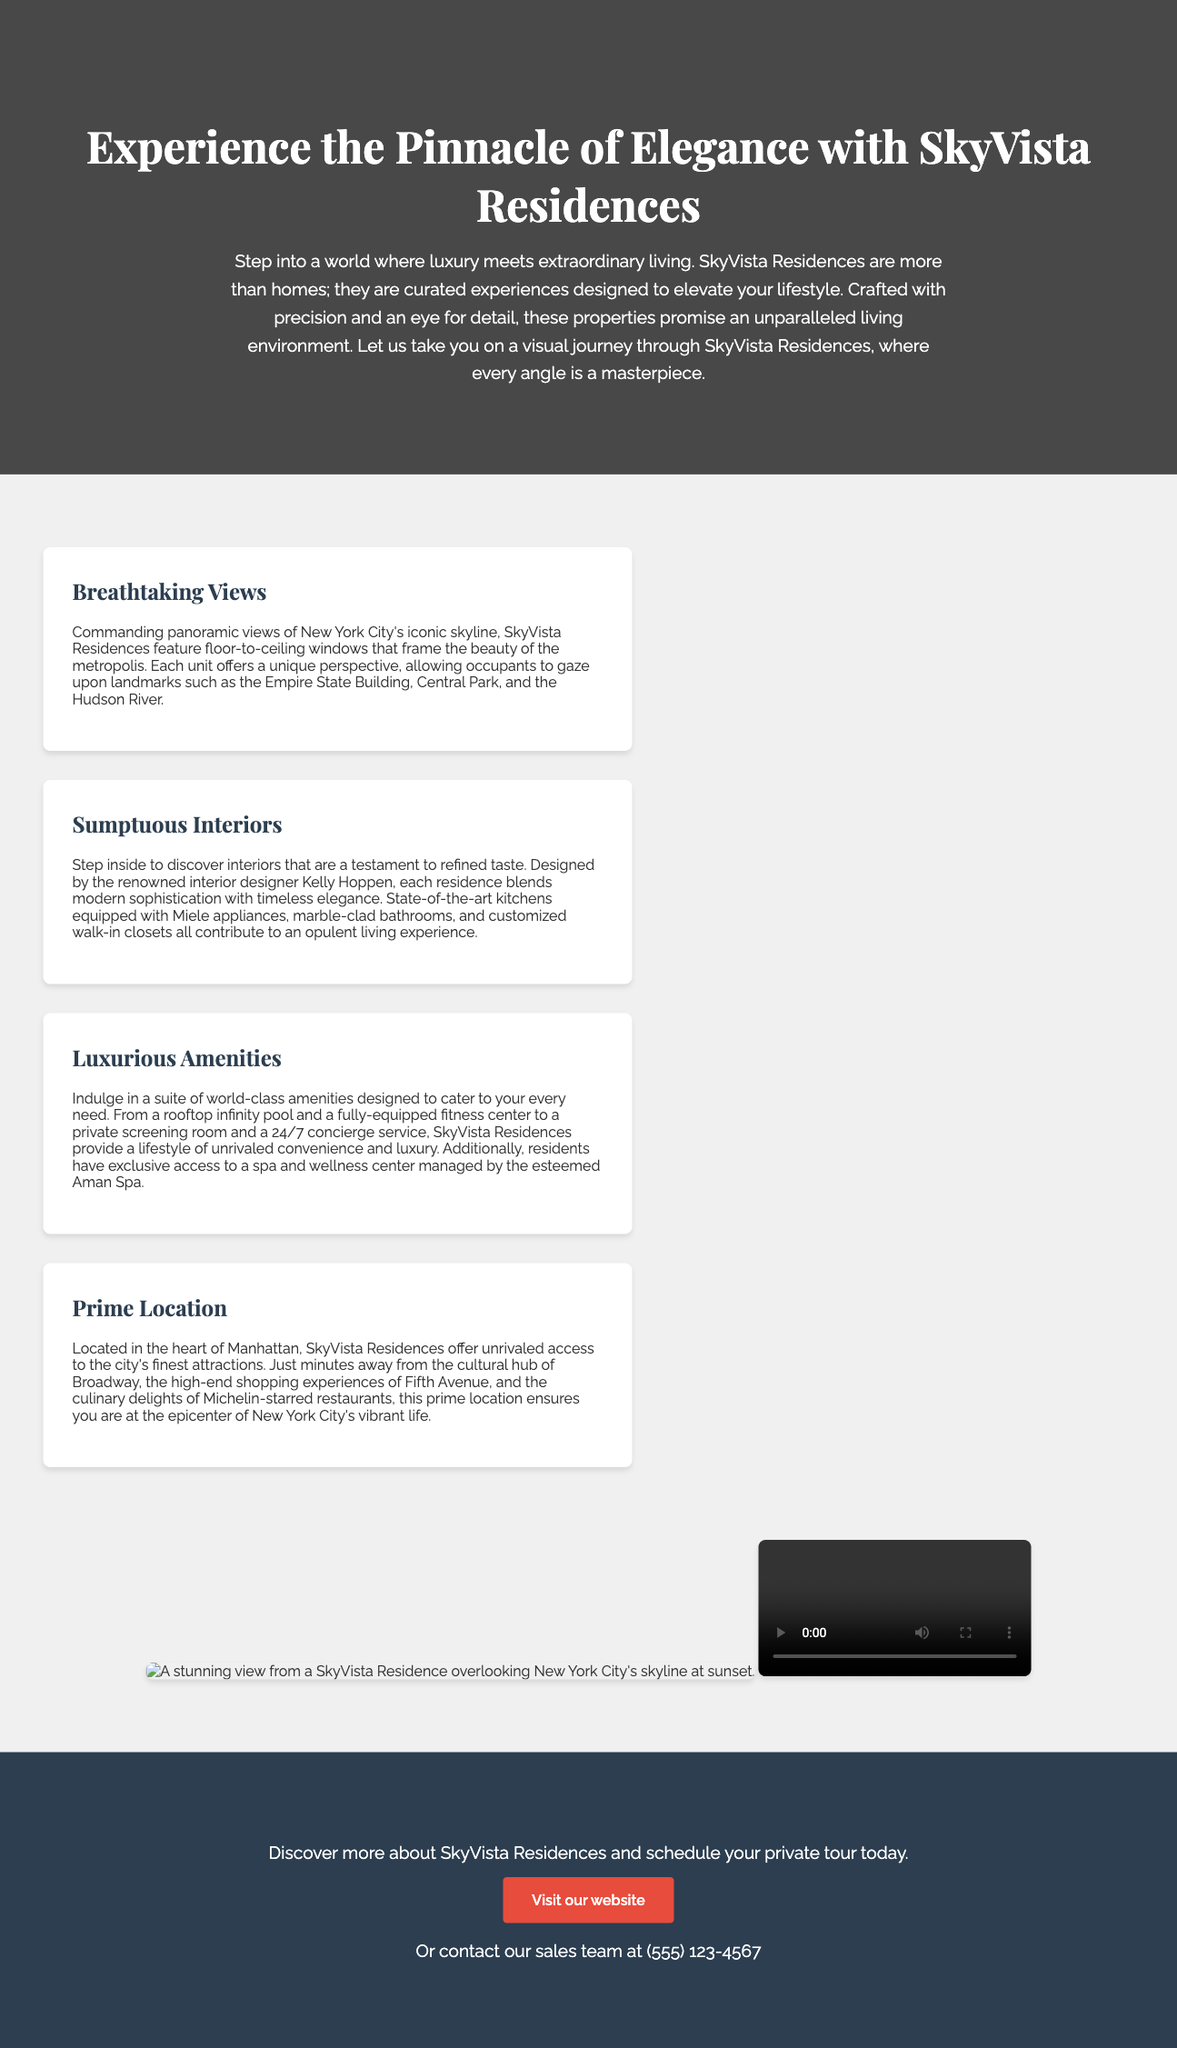What is the name of the real estate development? The advertisement prominently features SkyVista Residences as the luxury real estate development.
Answer: SkyVista Residences Who designed the interiors of the residences? The document states that the renowned interior designer Kelly Hoppen designed the interiors of the residences.
Answer: Kelly Hoppen What is one of the amenities mentioned in the advertisement? The ad lists luxurious amenities, one of which is a rooftop infinity pool.
Answer: Rooftop infinity pool Where is SkyVista Residences located? The advertisement specifies that the residences are located in the heart of Manhattan, New York City.
Answer: Manhattan What type of visuals are used in the advertisement? The advertisement employs panoramic visuals and rich storytelling to captivate viewers.
Answer: Panoramic visuals What is the primary color of the call-to-action button? The advertisement describes the call-to-action button as having a background color.
Answer: Red How can prospective buyers schedule a tour? They can schedule a tour through the contact information provided in the advertisement.
Answer: By contacting the sales team What does the intro segment emphasize? The introduction emphasizes that the residences are curated experiences designed to elevate lifestyle.
Answer: Curated experiences What landmark can be viewed from the residences? The advertisement indicates that the residences offer views of landmarks like the Empire State Building.
Answer: Empire State Building 